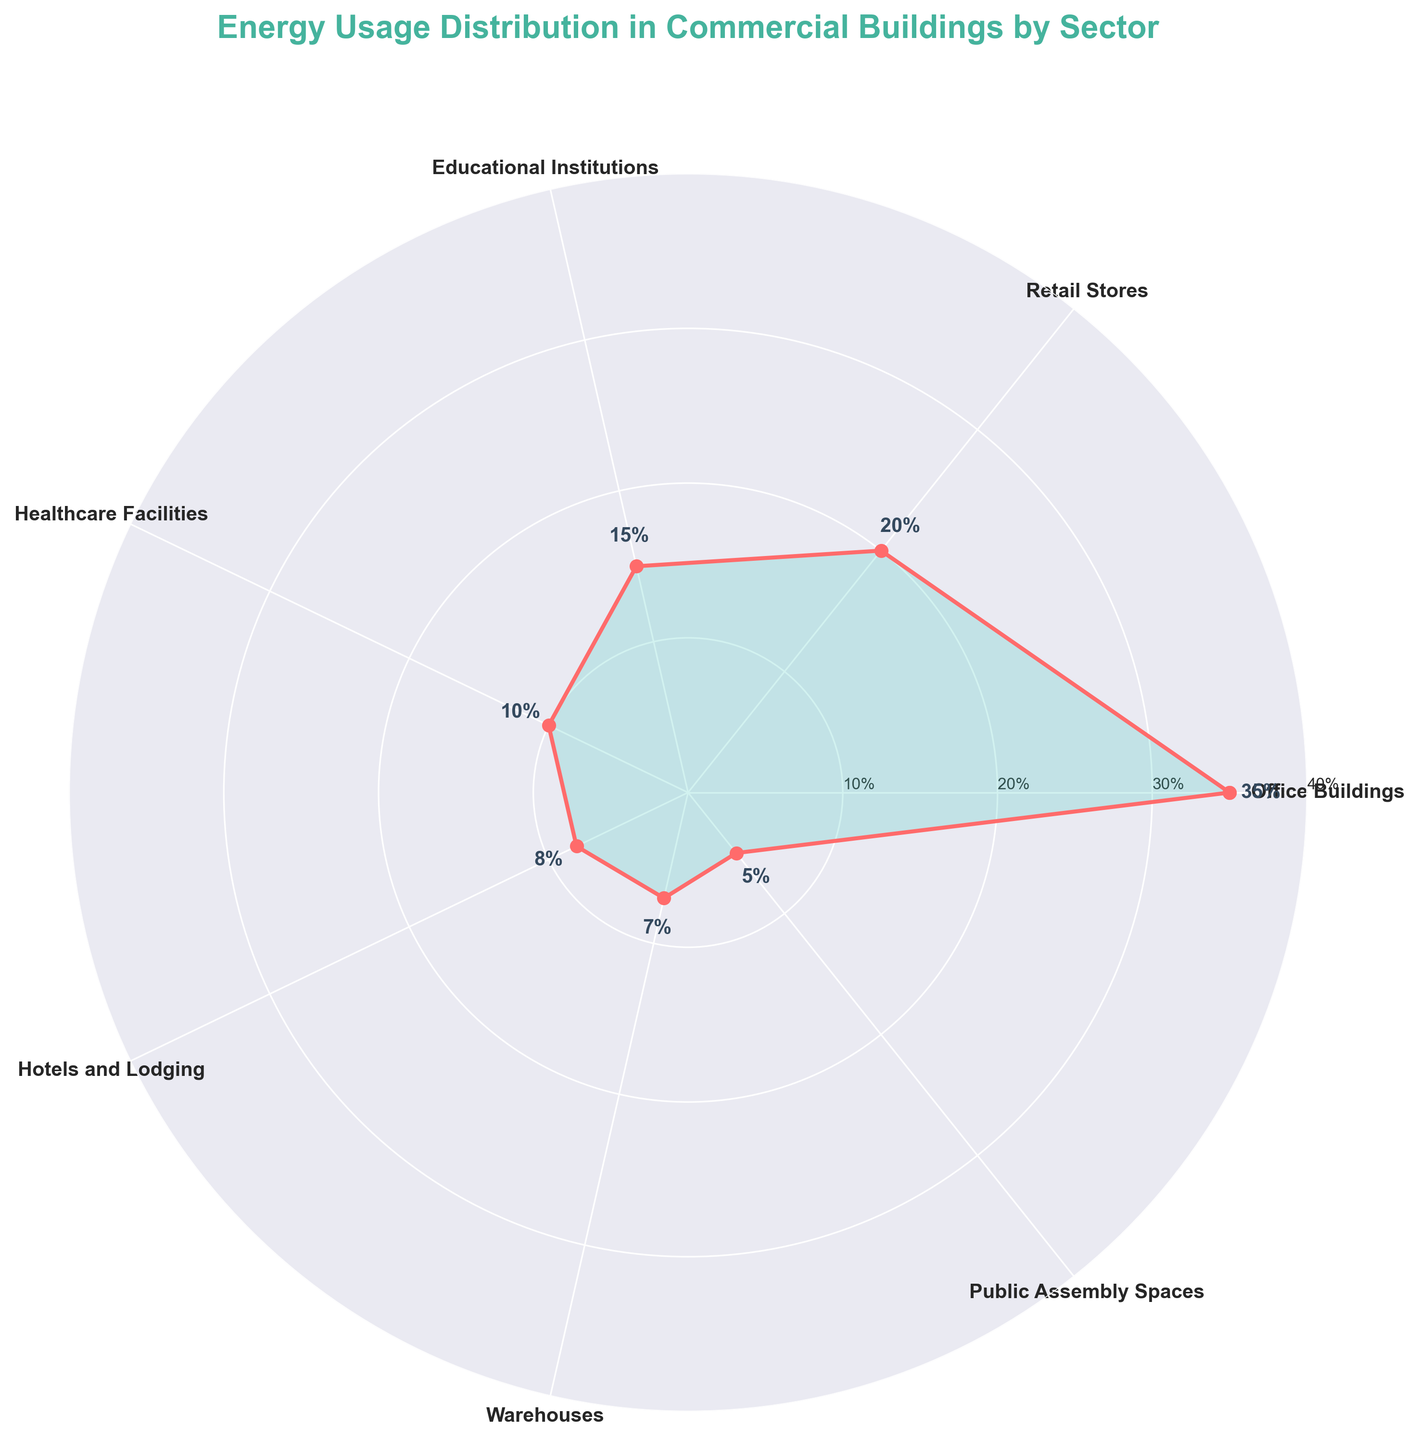What is the title of the figure? The title is located at the top of the figure, and it is usually the biggest text with bold font.
Answer: Energy Usage Distribution in Commercial Buildings by Sector What percentage of energy usage is attributed to Office Buildings? Office Buildings are one of the sectors listed around the perimeter of the polar chart. The percentage is written near the corresponding data point.
Answer: 35% Which sector uses the least energy? The sector using the least energy can be identified by looking for the smallest percentage value around the perimeter of the chart.
Answer: Public Assembly Spaces What is the combined percentage of energy usage for Healthcare Facilities and Hotels and Lodging? Find the percentages for Healthcare Facilities (10%) and Hotels and Lodging (8%) from the labels and add them together: 10% + 8% = 18%
Answer: 18% Which sector uses more energy: Retail Stores or Warehouses? Compare the two percentages for Retail Stores (20%) and Warehouses (7%) listed around the chart. Retail Stores have a higher percentage.
Answer: Retail Stores How much more energy does Educational Institutions use compared to Public Assembly Spaces? Find the percentage for Educational Institutions (15%) and Public Assembly Spaces (5%), then subtract the smaller percentage from the larger one: 15% - 5% = 10%.
Answer: 10% What is the average percentage of energy usage across all the sectors? Sum the percentages of all sectors: 35 + 20 + 15 + 10 + 8 + 7 + 5 = 100, then divide by the number of sectors (7): 100 / 7 ≈ 14.29%.
Answer: 14.29% How are the sectors represented visually on the chart? The sectors are represented by data points connected by lines to form a closed shape. Each point is labeled with the sector name and percentage, and areas inside the shape are filled with color.
Answer: Data points connected by lines and filled color How does the plot visually represent the proportion of energy usage for each sector? The plot uses the angle and position of data points to represent each sector's proportion, with larger percentages resulting in points farther from the center.
Answer: By angle and distance from the center 